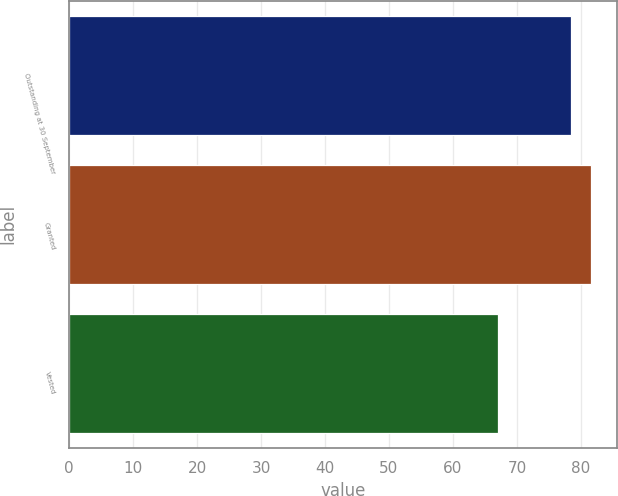<chart> <loc_0><loc_0><loc_500><loc_500><bar_chart><fcel>Outstanding at 30 September<fcel>Granted<fcel>Vested<nl><fcel>78.51<fcel>81.57<fcel>67.12<nl></chart> 